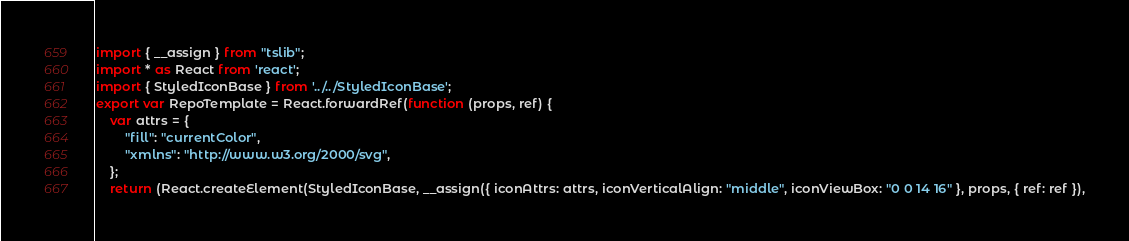Convert code to text. <code><loc_0><loc_0><loc_500><loc_500><_JavaScript_>import { __assign } from "tslib";
import * as React from 'react';
import { StyledIconBase } from '../../StyledIconBase';
export var RepoTemplate = React.forwardRef(function (props, ref) {
    var attrs = {
        "fill": "currentColor",
        "xmlns": "http://www.w3.org/2000/svg",
    };
    return (React.createElement(StyledIconBase, __assign({ iconAttrs: attrs, iconVerticalAlign: "middle", iconViewBox: "0 0 14 16" }, props, { ref: ref }),</code> 